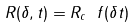<formula> <loc_0><loc_0><loc_500><loc_500>R ( \delta , t ) = R _ { c } \ f ( \delta t )</formula> 